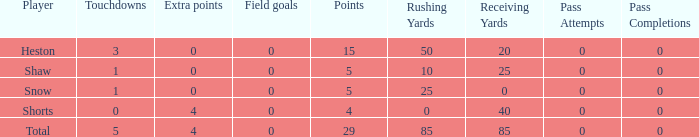What is the total number of field goals for a player that had less than 3 touchdowns, had 4 points, and had less than 4 extra points? 0.0. 